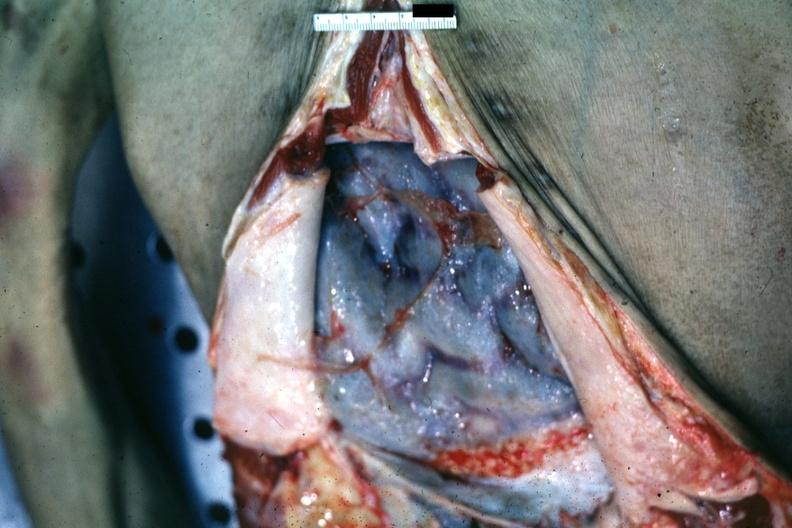what is opened abdomen with ischemic appearing intestines bound?
Answer the question using a single word or phrase. By neoplastic adhesions good but not the best ovarian papillary adenocarcinoma 